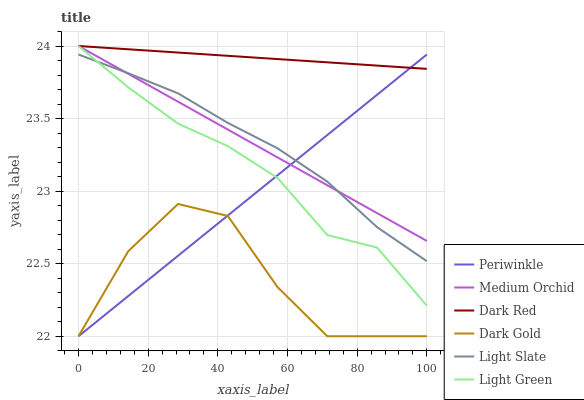Does Dark Gold have the minimum area under the curve?
Answer yes or no. Yes. Does Dark Red have the maximum area under the curve?
Answer yes or no. Yes. Does Light Slate have the minimum area under the curve?
Answer yes or no. No. Does Light Slate have the maximum area under the curve?
Answer yes or no. No. Is Medium Orchid the smoothest?
Answer yes or no. Yes. Is Dark Gold the roughest?
Answer yes or no. Yes. Is Light Slate the smoothest?
Answer yes or no. No. Is Light Slate the roughest?
Answer yes or no. No. Does Dark Gold have the lowest value?
Answer yes or no. Yes. Does Light Slate have the lowest value?
Answer yes or no. No. Does Light Green have the highest value?
Answer yes or no. Yes. Does Light Slate have the highest value?
Answer yes or no. No. Is Light Slate less than Dark Red?
Answer yes or no. Yes. Is Dark Red greater than Light Slate?
Answer yes or no. Yes. Does Periwinkle intersect Medium Orchid?
Answer yes or no. Yes. Is Periwinkle less than Medium Orchid?
Answer yes or no. No. Is Periwinkle greater than Medium Orchid?
Answer yes or no. No. Does Light Slate intersect Dark Red?
Answer yes or no. No. 